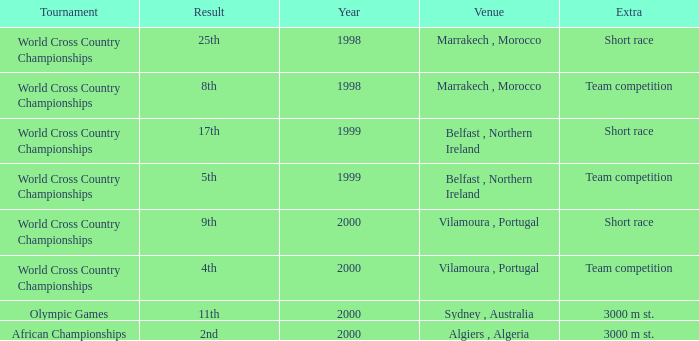Tell me the venue for extra of short race and year less than 1999 Marrakech , Morocco. 